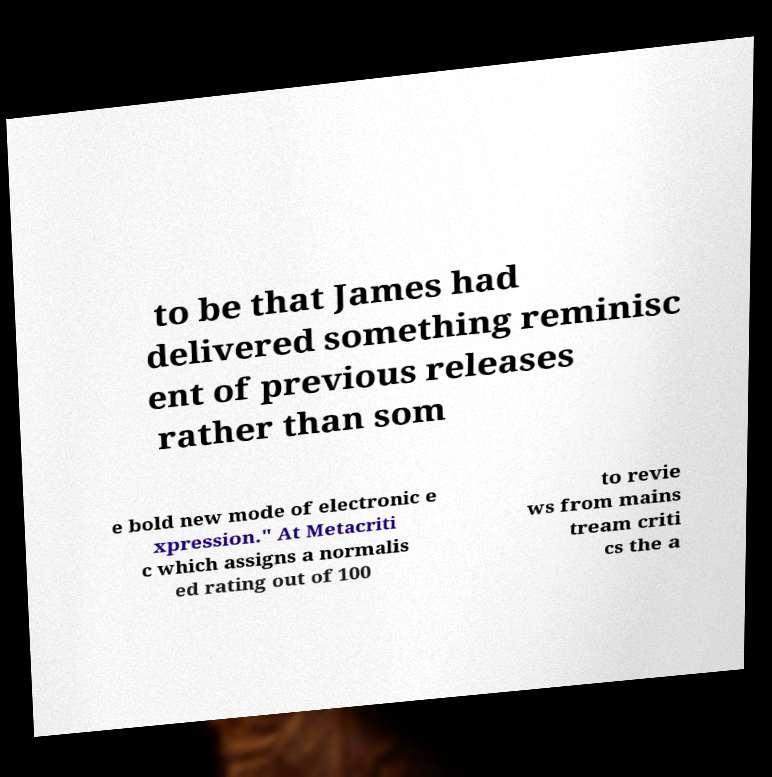I need the written content from this picture converted into text. Can you do that? to be that James had delivered something reminisc ent of previous releases rather than som e bold new mode of electronic e xpression." At Metacriti c which assigns a normalis ed rating out of 100 to revie ws from mains tream criti cs the a 